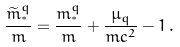Convert formula to latex. <formula><loc_0><loc_0><loc_500><loc_500>\frac { \widetilde { m } _ { ^ { * } } ^ { q } } { m } = \frac { m _ { ^ { * } } ^ { q } } { m } + \frac { \mu _ { q } } { m c ^ { 2 } } - 1 \, .</formula> 